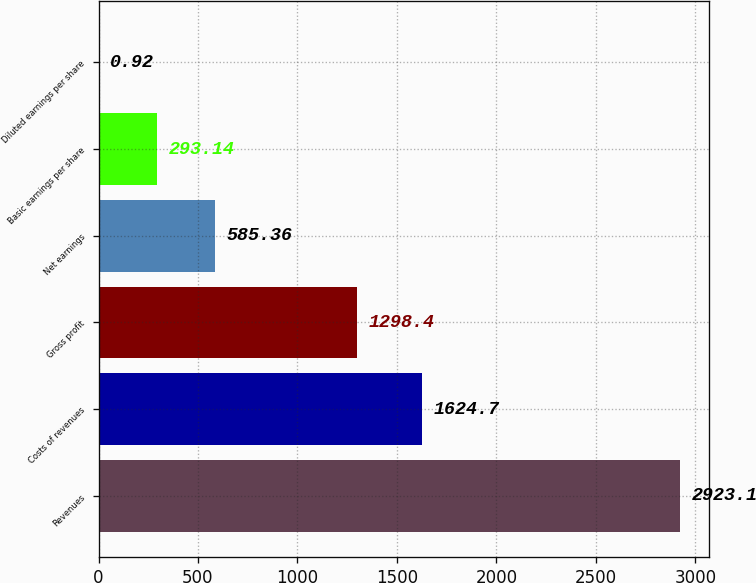Convert chart. <chart><loc_0><loc_0><loc_500><loc_500><bar_chart><fcel>Revenues<fcel>Costs of revenues<fcel>Gross profit<fcel>Net earnings<fcel>Basic earnings per share<fcel>Diluted earnings per share<nl><fcel>2923.1<fcel>1624.7<fcel>1298.4<fcel>585.36<fcel>293.14<fcel>0.92<nl></chart> 